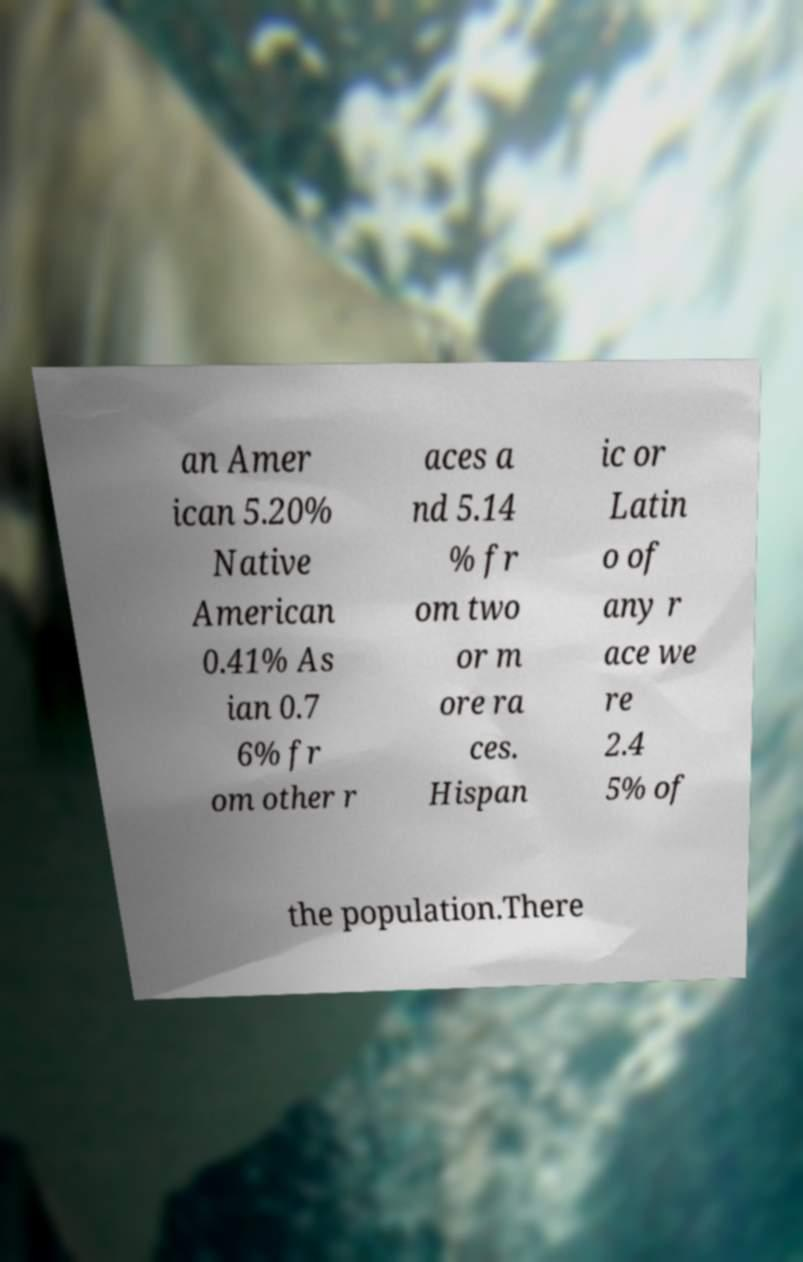For documentation purposes, I need the text within this image transcribed. Could you provide that? an Amer ican 5.20% Native American 0.41% As ian 0.7 6% fr om other r aces a nd 5.14 % fr om two or m ore ra ces. Hispan ic or Latin o of any r ace we re 2.4 5% of the population.There 